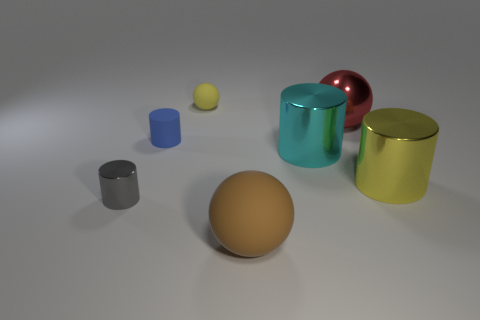What is the color of the other metallic thing that is the same size as the blue thing?
Offer a terse response. Gray. What is the size of the metal cylinder that is left of the blue matte cylinder?
Give a very brief answer. Small. Is there a small object that is behind the matte sphere behind the yellow cylinder?
Offer a very short reply. No. Is the material of the yellow object right of the big brown matte ball the same as the brown thing?
Make the answer very short. No. How many things are both in front of the yellow cylinder and left of the tiny yellow rubber sphere?
Offer a terse response. 1. How many small cubes have the same material as the gray object?
Your answer should be compact. 0. What color is the small thing that is the same material as the yellow ball?
Offer a terse response. Blue. Is the number of large gray metal blocks less than the number of red metal things?
Offer a very short reply. Yes. What material is the small thing behind the big ball right of the big object that is in front of the small gray metallic object made of?
Provide a short and direct response. Rubber. What is the material of the big red sphere?
Make the answer very short. Metal. 